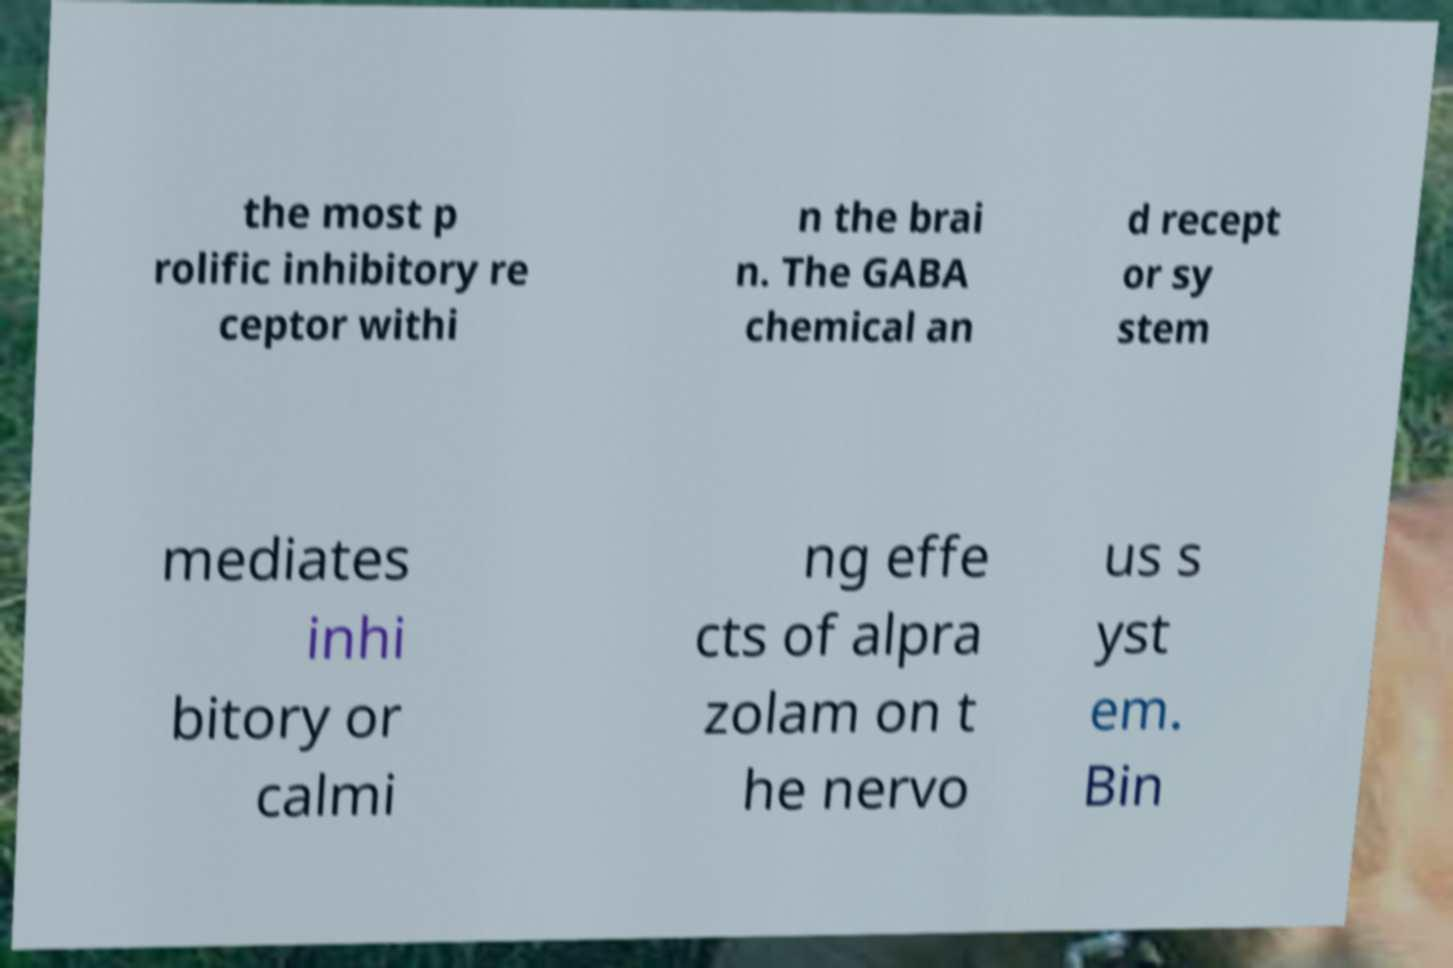Please read and relay the text visible in this image. What does it say? the most p rolific inhibitory re ceptor withi n the brai n. The GABA chemical an d recept or sy stem mediates inhi bitory or calmi ng effe cts of alpra zolam on t he nervo us s yst em. Bin 